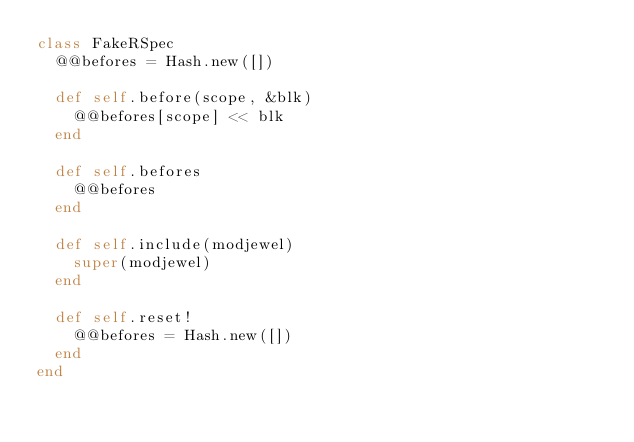<code> <loc_0><loc_0><loc_500><loc_500><_Ruby_>class FakeRSpec
  @@befores = Hash.new([])

  def self.before(scope, &blk)
    @@befores[scope] << blk
  end

  def self.befores
    @@befores
  end

  def self.include(modjewel)
    super(modjewel)
  end

  def self.reset!
    @@befores = Hash.new([])
  end
end
</code> 